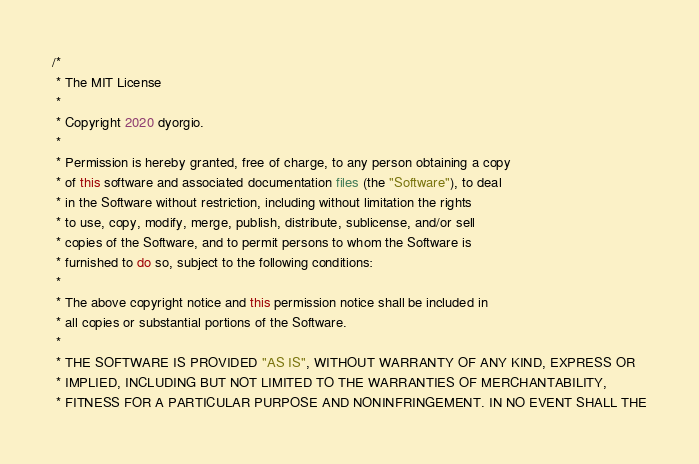<code> <loc_0><loc_0><loc_500><loc_500><_Java_>/*
 * The MIT License
 *
 * Copyright 2020 dyorgio.
 *
 * Permission is hereby granted, free of charge, to any person obtaining a copy
 * of this software and associated documentation files (the "Software"), to deal
 * in the Software without restriction, including without limitation the rights
 * to use, copy, modify, merge, publish, distribute, sublicense, and/or sell
 * copies of the Software, and to permit persons to whom the Software is
 * furnished to do so, subject to the following conditions:
 *
 * The above copyright notice and this permission notice shall be included in
 * all copies or substantial portions of the Software.
 *
 * THE SOFTWARE IS PROVIDED "AS IS", WITHOUT WARRANTY OF ANY KIND, EXPRESS OR
 * IMPLIED, INCLUDING BUT NOT LIMITED TO THE WARRANTIES OF MERCHANTABILITY,
 * FITNESS FOR A PARTICULAR PURPOSE AND NONINFRINGEMENT. IN NO EVENT SHALL THE</code> 